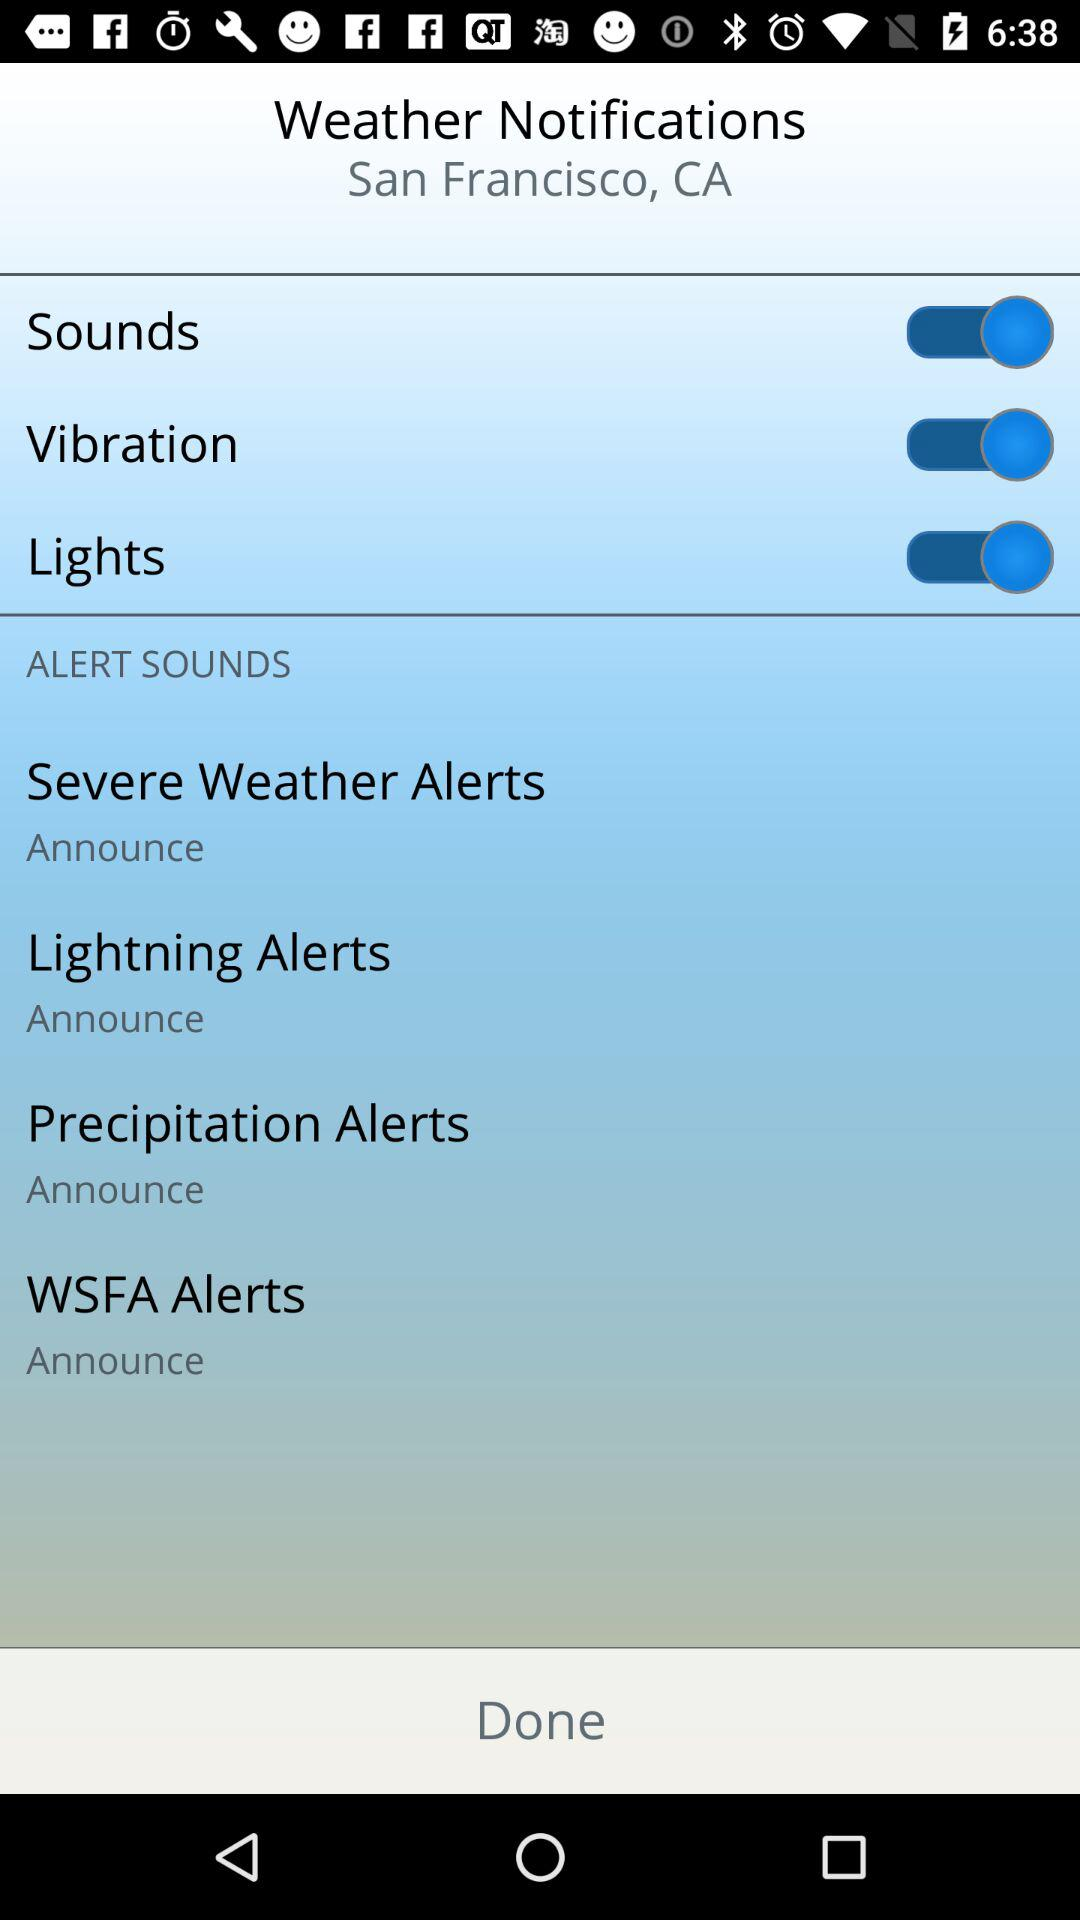What is the status of the "Vibration" setting? The status of the "Vibration" setting is "on". 